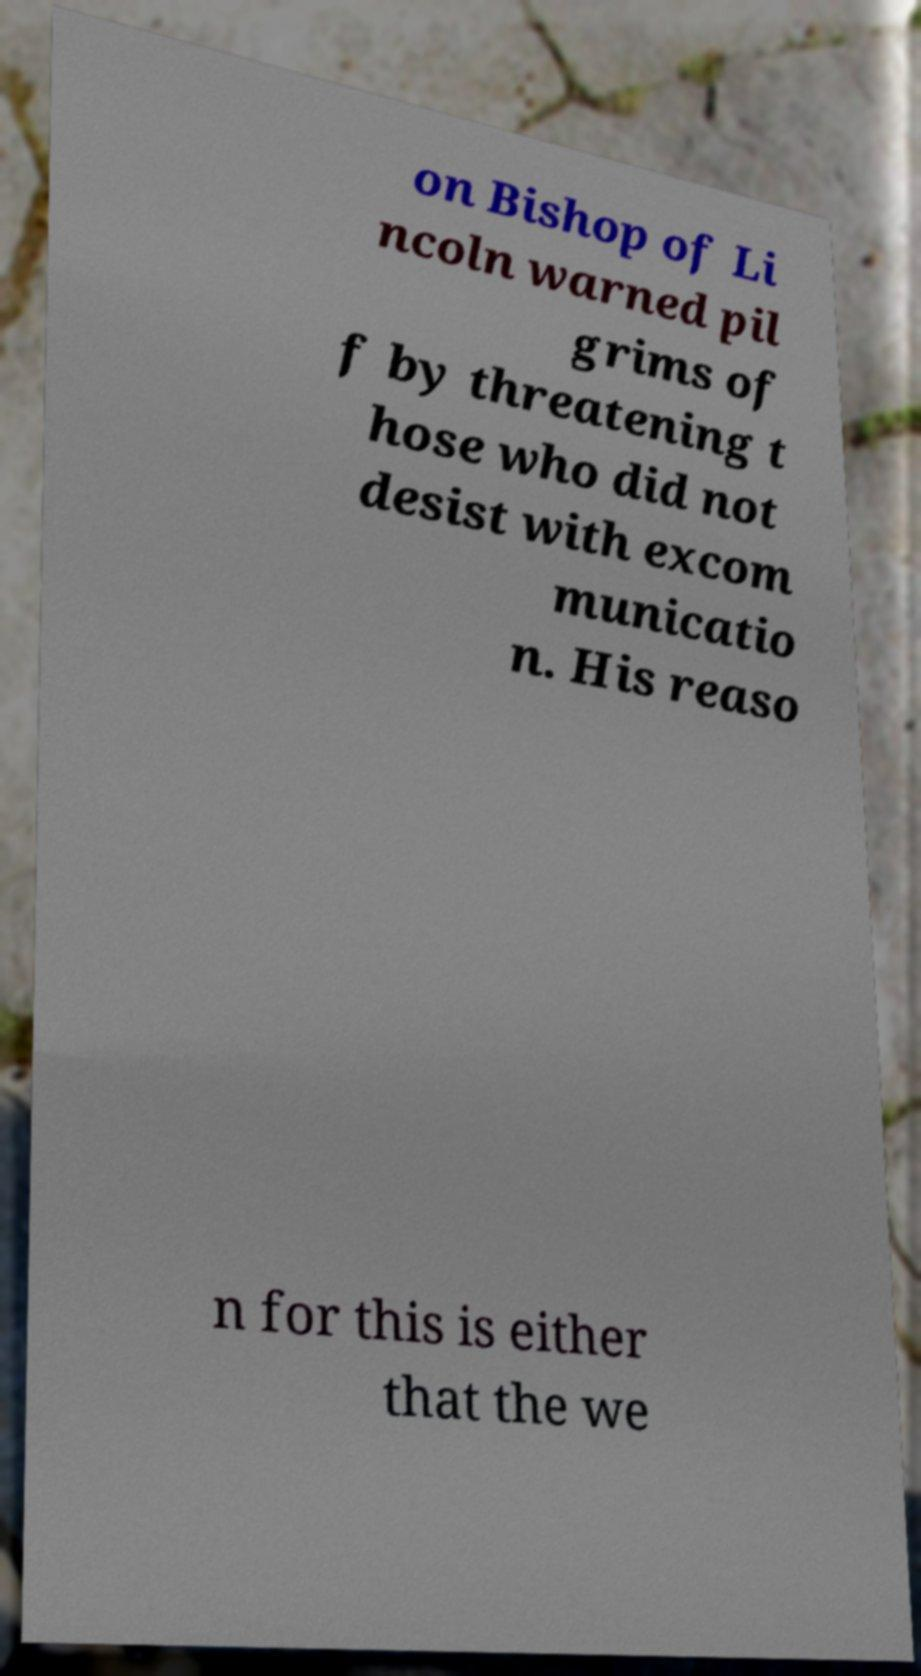I need the written content from this picture converted into text. Can you do that? on Bishop of Li ncoln warned pil grims of f by threatening t hose who did not desist with excom municatio n. His reaso n for this is either that the we 